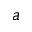<formula> <loc_0><loc_0><loc_500><loc_500>a</formula> 